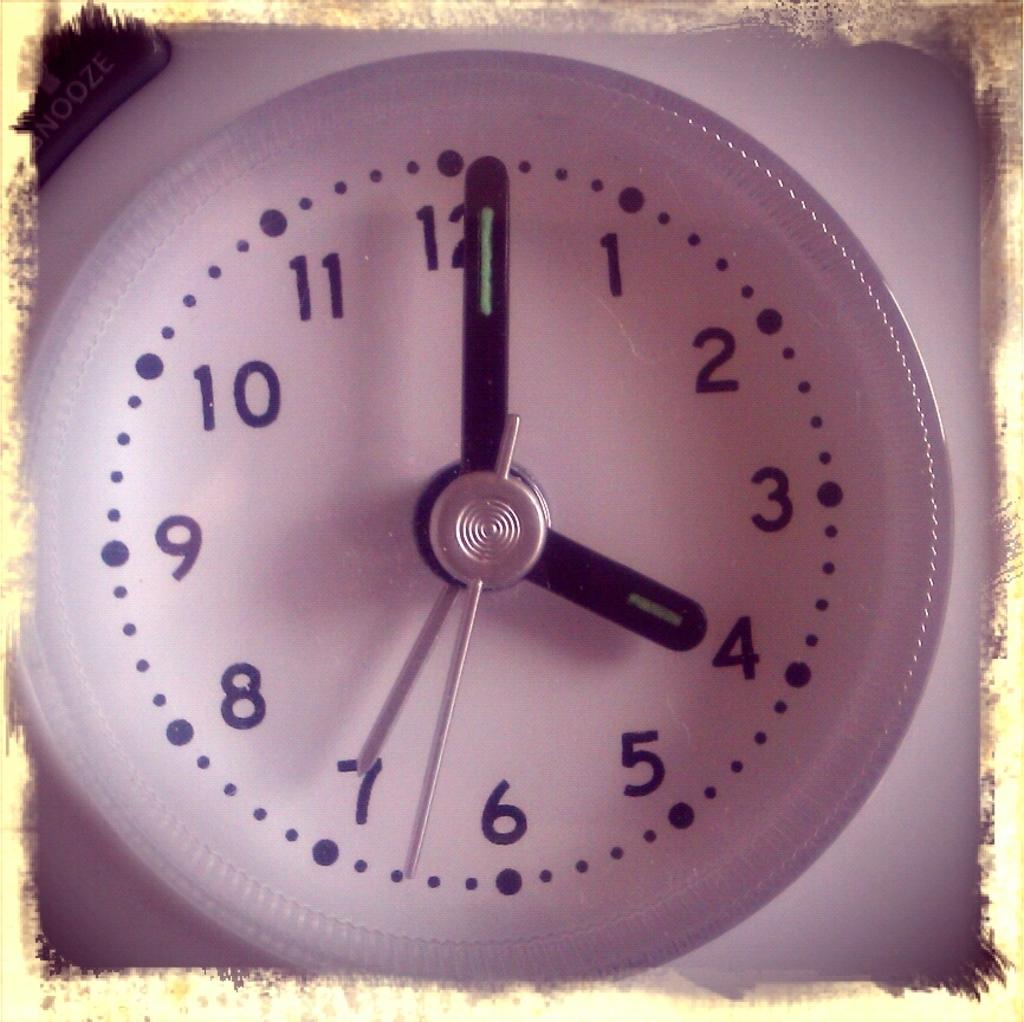What time is the clock at?
Provide a succinct answer. 4:01. The big and little and show that the time is what?
Your answer should be compact. 4:01. 